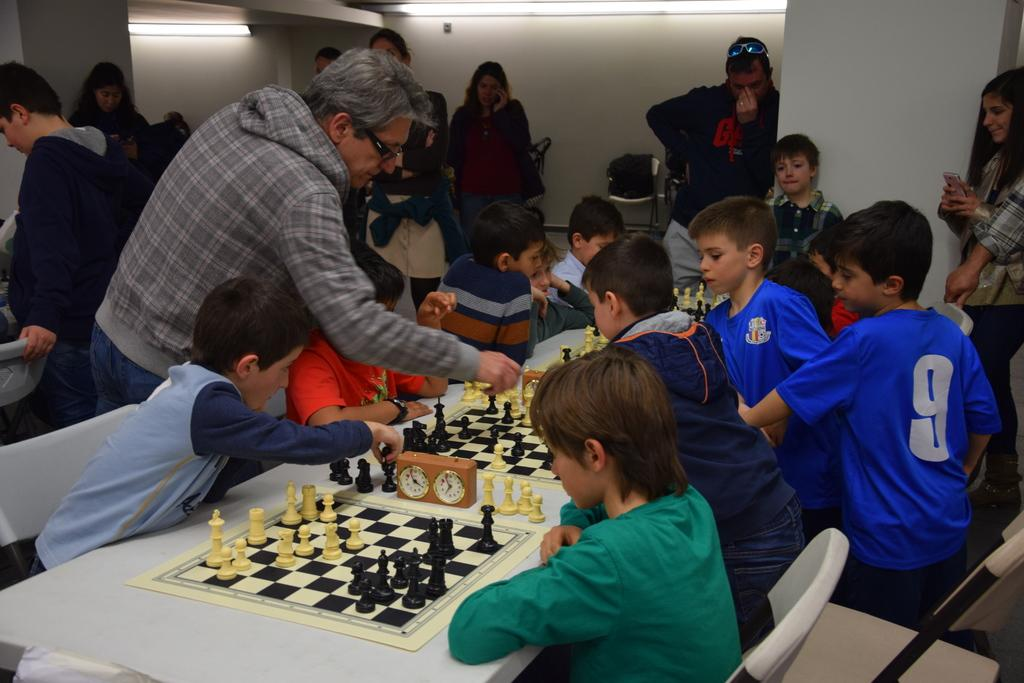What activity are the kids engaged in within the image? The kids are playing chess in the image. What kind of interaction is taking place between the kids? The chess game appears to be a competition. Are there any other people present in the image besides the kids playing chess? Yes, there are adults watching the kids play chess in the background and on the sides of the image. What type of car can be seen in the image? There is no car present in the image; it features kids playing chess with adults watching. What news event is being discussed by the kids playing chess? There is no news event being discussed in the image; the focus is on the chess game. 